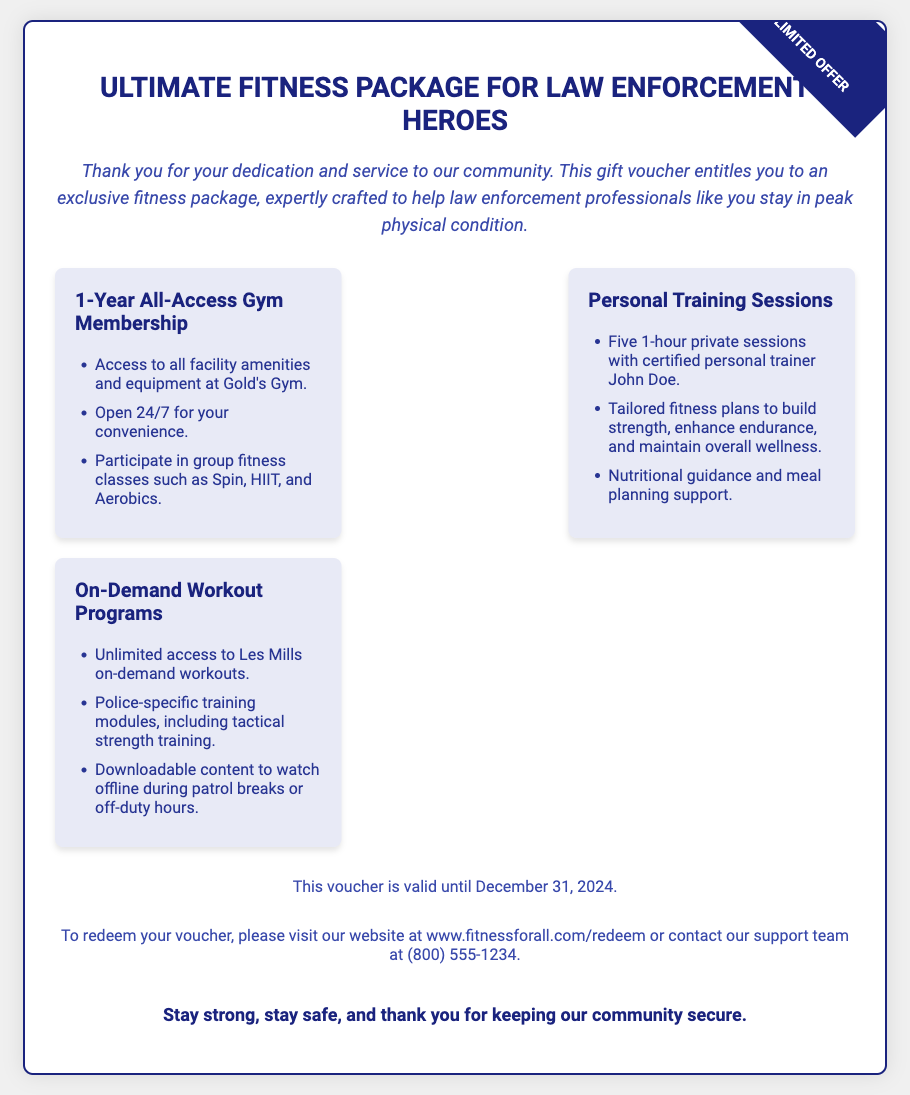What is the title of the fitness package? The title of the fitness package is prominently stated at the top of the voucher.
Answer: Ultimate Fitness Package for Law Enforcement Heroes How long is the gym membership valid for? The document specifies the duration of the gym membership directly within the included items.
Answer: 1-Year How many personal training sessions are included? The number of personal training sessions is listed under the personal training section in the voucher.
Answer: Five What type of on-demand workouts are provided? The voucher details the specific type of workouts available in the on-demand section.
Answer: Les Mills on-demand workouts What is the expiration date of the voucher? The expiration date is clearly mentioned towards the end of the document.
Answer: December 31, 2024 Who is the certified personal trainer mentioned? The name of the personal trainer is highlighted within the personal training sessions section.
Answer: John Doe What should someone do to redeem their voucher? The document provides specific instructions for redeeming the voucher in the contact information section.
Answer: Visit the website or contact support What is the contact number for support? The contact number is shown in the contact info section of the voucher.
Answer: (800) 555-1234 